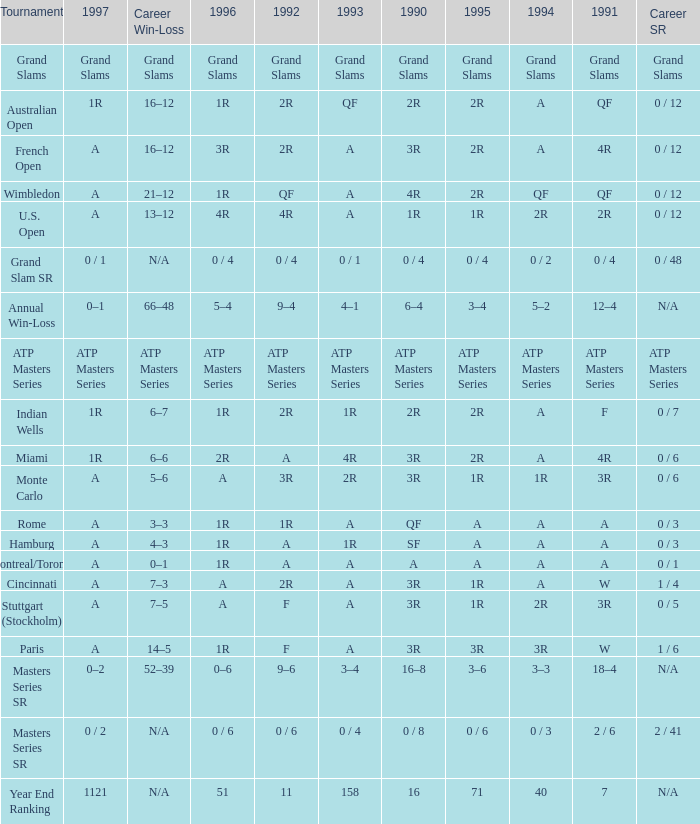What is Tournament, when Career SR is "ATP Masters Series"? ATP Masters Series. 